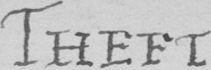Please provide the text content of this handwritten line. THEFT 